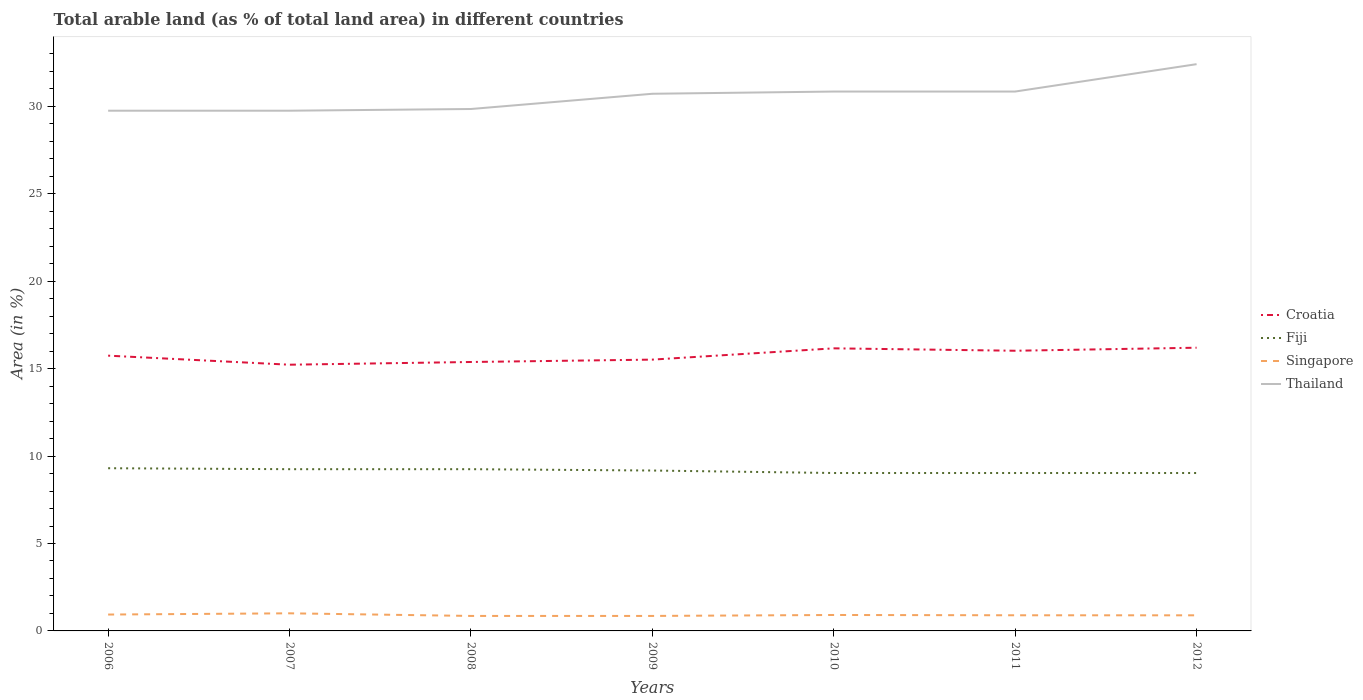How many different coloured lines are there?
Give a very brief answer. 4. Does the line corresponding to Fiji intersect with the line corresponding to Croatia?
Your answer should be compact. No. Is the number of lines equal to the number of legend labels?
Your answer should be very brief. Yes. Across all years, what is the maximum percentage of arable land in Fiji?
Ensure brevity in your answer.  9.03. In which year was the percentage of arable land in Thailand maximum?
Your answer should be very brief. 2006. What is the total percentage of arable land in Singapore in the graph?
Offer a terse response. 0.02. What is the difference between the highest and the second highest percentage of arable land in Croatia?
Keep it short and to the point. 0.97. What is the difference between the highest and the lowest percentage of arable land in Thailand?
Offer a terse response. 4. Is the percentage of arable land in Fiji strictly greater than the percentage of arable land in Singapore over the years?
Offer a very short reply. No. How many lines are there?
Ensure brevity in your answer.  4. What is the difference between two consecutive major ticks on the Y-axis?
Give a very brief answer. 5. How are the legend labels stacked?
Give a very brief answer. Vertical. What is the title of the graph?
Make the answer very short. Total arable land (as % of total land area) in different countries. What is the label or title of the X-axis?
Keep it short and to the point. Years. What is the label or title of the Y-axis?
Give a very brief answer. Area (in %). What is the Area (in %) in Croatia in 2006?
Make the answer very short. 15.74. What is the Area (in %) in Fiji in 2006?
Provide a succinct answer. 9.3. What is the Area (in %) of Singapore in 2006?
Provide a short and direct response. 0.94. What is the Area (in %) of Thailand in 2006?
Offer a terse response. 29.75. What is the Area (in %) of Croatia in 2007?
Give a very brief answer. 15.23. What is the Area (in %) in Fiji in 2007?
Your response must be concise. 9.25. What is the Area (in %) in Singapore in 2007?
Your response must be concise. 1.01. What is the Area (in %) in Thailand in 2007?
Give a very brief answer. 29.75. What is the Area (in %) in Croatia in 2008?
Make the answer very short. 15.38. What is the Area (in %) in Fiji in 2008?
Give a very brief answer. 9.25. What is the Area (in %) in Singapore in 2008?
Provide a short and direct response. 0.86. What is the Area (in %) of Thailand in 2008?
Your response must be concise. 29.85. What is the Area (in %) of Croatia in 2009?
Ensure brevity in your answer.  15.52. What is the Area (in %) of Fiji in 2009?
Your answer should be compact. 9.17. What is the Area (in %) of Singapore in 2009?
Make the answer very short. 0.86. What is the Area (in %) in Thailand in 2009?
Keep it short and to the point. 30.72. What is the Area (in %) in Croatia in 2010?
Provide a succinct answer. 16.16. What is the Area (in %) of Fiji in 2010?
Your answer should be compact. 9.03. What is the Area (in %) in Singapore in 2010?
Provide a succinct answer. 0.91. What is the Area (in %) of Thailand in 2010?
Offer a terse response. 30.85. What is the Area (in %) of Croatia in 2011?
Make the answer very short. 16.02. What is the Area (in %) in Fiji in 2011?
Provide a succinct answer. 9.03. What is the Area (in %) of Singapore in 2011?
Keep it short and to the point. 0.89. What is the Area (in %) in Thailand in 2011?
Keep it short and to the point. 30.85. What is the Area (in %) in Croatia in 2012?
Give a very brief answer. 16.2. What is the Area (in %) of Fiji in 2012?
Your answer should be very brief. 9.03. What is the Area (in %) of Singapore in 2012?
Offer a terse response. 0.89. What is the Area (in %) of Thailand in 2012?
Offer a terse response. 32.41. Across all years, what is the maximum Area (in %) of Croatia?
Your answer should be compact. 16.2. Across all years, what is the maximum Area (in %) of Fiji?
Give a very brief answer. 9.3. Across all years, what is the maximum Area (in %) in Singapore?
Ensure brevity in your answer.  1.01. Across all years, what is the maximum Area (in %) of Thailand?
Your answer should be compact. 32.41. Across all years, what is the minimum Area (in %) of Croatia?
Provide a succinct answer. 15.23. Across all years, what is the minimum Area (in %) of Fiji?
Provide a succinct answer. 9.03. Across all years, what is the minimum Area (in %) of Singapore?
Offer a very short reply. 0.86. Across all years, what is the minimum Area (in %) in Thailand?
Give a very brief answer. 29.75. What is the total Area (in %) in Croatia in the graph?
Your answer should be compact. 110.25. What is the total Area (in %) of Fiji in the graph?
Provide a succinct answer. 64.07. What is the total Area (in %) in Singapore in the graph?
Offer a terse response. 6.36. What is the total Area (in %) of Thailand in the graph?
Make the answer very short. 214.19. What is the difference between the Area (in %) of Croatia in 2006 and that in 2007?
Your answer should be compact. 0.52. What is the difference between the Area (in %) of Fiji in 2006 and that in 2007?
Give a very brief answer. 0.05. What is the difference between the Area (in %) of Singapore in 2006 and that in 2007?
Your answer should be very brief. -0.07. What is the difference between the Area (in %) of Croatia in 2006 and that in 2008?
Your response must be concise. 0.36. What is the difference between the Area (in %) of Fiji in 2006 and that in 2008?
Your answer should be compact. 0.05. What is the difference between the Area (in %) in Singapore in 2006 and that in 2008?
Provide a short and direct response. 0.08. What is the difference between the Area (in %) of Thailand in 2006 and that in 2008?
Give a very brief answer. -0.1. What is the difference between the Area (in %) in Croatia in 2006 and that in 2009?
Make the answer very short. 0.23. What is the difference between the Area (in %) of Fiji in 2006 and that in 2009?
Provide a short and direct response. 0.13. What is the difference between the Area (in %) in Singapore in 2006 and that in 2009?
Make the answer very short. 0.08. What is the difference between the Area (in %) of Thailand in 2006 and that in 2009?
Your answer should be compact. -0.97. What is the difference between the Area (in %) in Croatia in 2006 and that in 2010?
Your response must be concise. -0.42. What is the difference between the Area (in %) in Fiji in 2006 and that in 2010?
Provide a succinct answer. 0.27. What is the difference between the Area (in %) in Singapore in 2006 and that in 2010?
Give a very brief answer. 0.02. What is the difference between the Area (in %) of Thailand in 2006 and that in 2010?
Keep it short and to the point. -1.1. What is the difference between the Area (in %) of Croatia in 2006 and that in 2011?
Offer a terse response. -0.28. What is the difference between the Area (in %) of Fiji in 2006 and that in 2011?
Make the answer very short. 0.27. What is the difference between the Area (in %) of Singapore in 2006 and that in 2011?
Give a very brief answer. 0.04. What is the difference between the Area (in %) in Thailand in 2006 and that in 2011?
Provide a short and direct response. -1.1. What is the difference between the Area (in %) of Croatia in 2006 and that in 2012?
Keep it short and to the point. -0.45. What is the difference between the Area (in %) of Fiji in 2006 and that in 2012?
Your answer should be compact. 0.27. What is the difference between the Area (in %) of Singapore in 2006 and that in 2012?
Offer a very short reply. 0.04. What is the difference between the Area (in %) of Thailand in 2006 and that in 2012?
Keep it short and to the point. -2.66. What is the difference between the Area (in %) of Croatia in 2007 and that in 2008?
Your answer should be very brief. -0.16. What is the difference between the Area (in %) in Fiji in 2007 and that in 2008?
Your response must be concise. 0. What is the difference between the Area (in %) in Singapore in 2007 and that in 2008?
Ensure brevity in your answer.  0.15. What is the difference between the Area (in %) of Thailand in 2007 and that in 2008?
Your answer should be compact. -0.1. What is the difference between the Area (in %) in Croatia in 2007 and that in 2009?
Provide a short and direct response. -0.29. What is the difference between the Area (in %) of Fiji in 2007 and that in 2009?
Offer a terse response. 0.08. What is the difference between the Area (in %) in Singapore in 2007 and that in 2009?
Provide a short and direct response. 0.15. What is the difference between the Area (in %) of Thailand in 2007 and that in 2009?
Give a very brief answer. -0.97. What is the difference between the Area (in %) in Croatia in 2007 and that in 2010?
Your response must be concise. -0.94. What is the difference between the Area (in %) in Fiji in 2007 and that in 2010?
Make the answer very short. 0.22. What is the difference between the Area (in %) of Singapore in 2007 and that in 2010?
Your answer should be compact. 0.1. What is the difference between the Area (in %) of Thailand in 2007 and that in 2010?
Give a very brief answer. -1.1. What is the difference between the Area (in %) in Croatia in 2007 and that in 2011?
Keep it short and to the point. -0.8. What is the difference between the Area (in %) of Fiji in 2007 and that in 2011?
Provide a short and direct response. 0.22. What is the difference between the Area (in %) in Singapore in 2007 and that in 2011?
Keep it short and to the point. 0.11. What is the difference between the Area (in %) in Thailand in 2007 and that in 2011?
Offer a terse response. -1.1. What is the difference between the Area (in %) of Croatia in 2007 and that in 2012?
Your answer should be compact. -0.97. What is the difference between the Area (in %) in Fiji in 2007 and that in 2012?
Offer a terse response. 0.22. What is the difference between the Area (in %) in Singapore in 2007 and that in 2012?
Offer a very short reply. 0.11. What is the difference between the Area (in %) of Thailand in 2007 and that in 2012?
Your answer should be very brief. -2.66. What is the difference between the Area (in %) in Croatia in 2008 and that in 2009?
Give a very brief answer. -0.14. What is the difference between the Area (in %) of Fiji in 2008 and that in 2009?
Make the answer very short. 0.08. What is the difference between the Area (in %) of Singapore in 2008 and that in 2009?
Ensure brevity in your answer.  0. What is the difference between the Area (in %) of Thailand in 2008 and that in 2009?
Offer a very short reply. -0.87. What is the difference between the Area (in %) in Croatia in 2008 and that in 2010?
Provide a short and direct response. -0.78. What is the difference between the Area (in %) of Fiji in 2008 and that in 2010?
Provide a short and direct response. 0.22. What is the difference between the Area (in %) of Singapore in 2008 and that in 2010?
Offer a terse response. -0.05. What is the difference between the Area (in %) of Thailand in 2008 and that in 2010?
Provide a short and direct response. -1. What is the difference between the Area (in %) in Croatia in 2008 and that in 2011?
Offer a very short reply. -0.64. What is the difference between the Area (in %) in Fiji in 2008 and that in 2011?
Offer a terse response. 0.22. What is the difference between the Area (in %) in Singapore in 2008 and that in 2011?
Offer a terse response. -0.04. What is the difference between the Area (in %) of Thailand in 2008 and that in 2011?
Provide a succinct answer. -1. What is the difference between the Area (in %) of Croatia in 2008 and that in 2012?
Provide a succinct answer. -0.82. What is the difference between the Area (in %) in Fiji in 2008 and that in 2012?
Your answer should be compact. 0.22. What is the difference between the Area (in %) in Singapore in 2008 and that in 2012?
Make the answer very short. -0.04. What is the difference between the Area (in %) in Thailand in 2008 and that in 2012?
Keep it short and to the point. -2.56. What is the difference between the Area (in %) in Croatia in 2009 and that in 2010?
Provide a succinct answer. -0.65. What is the difference between the Area (in %) of Fiji in 2009 and that in 2010?
Offer a terse response. 0.14. What is the difference between the Area (in %) in Singapore in 2009 and that in 2010?
Give a very brief answer. -0.05. What is the difference between the Area (in %) of Thailand in 2009 and that in 2010?
Your answer should be compact. -0.13. What is the difference between the Area (in %) in Croatia in 2009 and that in 2011?
Your answer should be compact. -0.51. What is the difference between the Area (in %) in Fiji in 2009 and that in 2011?
Offer a terse response. 0.14. What is the difference between the Area (in %) in Singapore in 2009 and that in 2011?
Ensure brevity in your answer.  -0.04. What is the difference between the Area (in %) of Thailand in 2009 and that in 2011?
Provide a short and direct response. -0.13. What is the difference between the Area (in %) of Croatia in 2009 and that in 2012?
Offer a very short reply. -0.68. What is the difference between the Area (in %) of Fiji in 2009 and that in 2012?
Keep it short and to the point. 0.14. What is the difference between the Area (in %) in Singapore in 2009 and that in 2012?
Make the answer very short. -0.04. What is the difference between the Area (in %) in Thailand in 2009 and that in 2012?
Give a very brief answer. -1.69. What is the difference between the Area (in %) of Croatia in 2010 and that in 2011?
Make the answer very short. 0.14. What is the difference between the Area (in %) of Fiji in 2010 and that in 2011?
Offer a terse response. 0. What is the difference between the Area (in %) in Singapore in 2010 and that in 2011?
Provide a short and direct response. 0.02. What is the difference between the Area (in %) of Croatia in 2010 and that in 2012?
Offer a very short reply. -0.04. What is the difference between the Area (in %) in Singapore in 2010 and that in 2012?
Your answer should be very brief. 0.02. What is the difference between the Area (in %) of Thailand in 2010 and that in 2012?
Ensure brevity in your answer.  -1.57. What is the difference between the Area (in %) of Croatia in 2011 and that in 2012?
Offer a very short reply. -0.17. What is the difference between the Area (in %) in Fiji in 2011 and that in 2012?
Your answer should be compact. 0. What is the difference between the Area (in %) of Singapore in 2011 and that in 2012?
Your response must be concise. 0. What is the difference between the Area (in %) of Thailand in 2011 and that in 2012?
Your response must be concise. -1.57. What is the difference between the Area (in %) of Croatia in 2006 and the Area (in %) of Fiji in 2007?
Your answer should be compact. 6.49. What is the difference between the Area (in %) in Croatia in 2006 and the Area (in %) in Singapore in 2007?
Your response must be concise. 14.74. What is the difference between the Area (in %) of Croatia in 2006 and the Area (in %) of Thailand in 2007?
Ensure brevity in your answer.  -14.01. What is the difference between the Area (in %) in Fiji in 2006 and the Area (in %) in Singapore in 2007?
Make the answer very short. 8.3. What is the difference between the Area (in %) in Fiji in 2006 and the Area (in %) in Thailand in 2007?
Your response must be concise. -20.45. What is the difference between the Area (in %) of Singapore in 2006 and the Area (in %) of Thailand in 2007?
Keep it short and to the point. -28.82. What is the difference between the Area (in %) of Croatia in 2006 and the Area (in %) of Fiji in 2008?
Your response must be concise. 6.49. What is the difference between the Area (in %) in Croatia in 2006 and the Area (in %) in Singapore in 2008?
Provide a succinct answer. 14.89. What is the difference between the Area (in %) of Croatia in 2006 and the Area (in %) of Thailand in 2008?
Ensure brevity in your answer.  -14.11. What is the difference between the Area (in %) of Fiji in 2006 and the Area (in %) of Singapore in 2008?
Ensure brevity in your answer.  8.45. What is the difference between the Area (in %) in Fiji in 2006 and the Area (in %) in Thailand in 2008?
Your response must be concise. -20.55. What is the difference between the Area (in %) in Singapore in 2006 and the Area (in %) in Thailand in 2008?
Offer a very short reply. -28.91. What is the difference between the Area (in %) of Croatia in 2006 and the Area (in %) of Fiji in 2009?
Offer a terse response. 6.57. What is the difference between the Area (in %) in Croatia in 2006 and the Area (in %) in Singapore in 2009?
Make the answer very short. 14.89. What is the difference between the Area (in %) in Croatia in 2006 and the Area (in %) in Thailand in 2009?
Make the answer very short. -14.98. What is the difference between the Area (in %) in Fiji in 2006 and the Area (in %) in Singapore in 2009?
Provide a succinct answer. 8.45. What is the difference between the Area (in %) of Fiji in 2006 and the Area (in %) of Thailand in 2009?
Make the answer very short. -21.42. What is the difference between the Area (in %) in Singapore in 2006 and the Area (in %) in Thailand in 2009?
Your answer should be compact. -29.78. What is the difference between the Area (in %) in Croatia in 2006 and the Area (in %) in Fiji in 2010?
Your answer should be compact. 6.71. What is the difference between the Area (in %) in Croatia in 2006 and the Area (in %) in Singapore in 2010?
Provide a short and direct response. 14.83. What is the difference between the Area (in %) of Croatia in 2006 and the Area (in %) of Thailand in 2010?
Keep it short and to the point. -15.1. What is the difference between the Area (in %) in Fiji in 2006 and the Area (in %) in Singapore in 2010?
Offer a terse response. 8.39. What is the difference between the Area (in %) in Fiji in 2006 and the Area (in %) in Thailand in 2010?
Offer a terse response. -21.54. What is the difference between the Area (in %) of Singapore in 2006 and the Area (in %) of Thailand in 2010?
Ensure brevity in your answer.  -29.91. What is the difference between the Area (in %) in Croatia in 2006 and the Area (in %) in Fiji in 2011?
Keep it short and to the point. 6.71. What is the difference between the Area (in %) in Croatia in 2006 and the Area (in %) in Singapore in 2011?
Your response must be concise. 14.85. What is the difference between the Area (in %) in Croatia in 2006 and the Area (in %) in Thailand in 2011?
Provide a succinct answer. -15.1. What is the difference between the Area (in %) in Fiji in 2006 and the Area (in %) in Singapore in 2011?
Your answer should be very brief. 8.41. What is the difference between the Area (in %) in Fiji in 2006 and the Area (in %) in Thailand in 2011?
Provide a succinct answer. -21.54. What is the difference between the Area (in %) of Singapore in 2006 and the Area (in %) of Thailand in 2011?
Keep it short and to the point. -29.91. What is the difference between the Area (in %) of Croatia in 2006 and the Area (in %) of Fiji in 2012?
Make the answer very short. 6.71. What is the difference between the Area (in %) of Croatia in 2006 and the Area (in %) of Singapore in 2012?
Offer a terse response. 14.85. What is the difference between the Area (in %) in Croatia in 2006 and the Area (in %) in Thailand in 2012?
Ensure brevity in your answer.  -16.67. What is the difference between the Area (in %) of Fiji in 2006 and the Area (in %) of Singapore in 2012?
Keep it short and to the point. 8.41. What is the difference between the Area (in %) in Fiji in 2006 and the Area (in %) in Thailand in 2012?
Give a very brief answer. -23.11. What is the difference between the Area (in %) in Singapore in 2006 and the Area (in %) in Thailand in 2012?
Provide a succinct answer. -31.48. What is the difference between the Area (in %) in Croatia in 2007 and the Area (in %) in Fiji in 2008?
Your answer should be very brief. 5.97. What is the difference between the Area (in %) in Croatia in 2007 and the Area (in %) in Singapore in 2008?
Give a very brief answer. 14.37. What is the difference between the Area (in %) in Croatia in 2007 and the Area (in %) in Thailand in 2008?
Offer a very short reply. -14.62. What is the difference between the Area (in %) of Fiji in 2007 and the Area (in %) of Singapore in 2008?
Offer a terse response. 8.39. What is the difference between the Area (in %) in Fiji in 2007 and the Area (in %) in Thailand in 2008?
Ensure brevity in your answer.  -20.6. What is the difference between the Area (in %) in Singapore in 2007 and the Area (in %) in Thailand in 2008?
Give a very brief answer. -28.84. What is the difference between the Area (in %) of Croatia in 2007 and the Area (in %) of Fiji in 2009?
Your response must be concise. 6.05. What is the difference between the Area (in %) of Croatia in 2007 and the Area (in %) of Singapore in 2009?
Provide a succinct answer. 14.37. What is the difference between the Area (in %) in Croatia in 2007 and the Area (in %) in Thailand in 2009?
Ensure brevity in your answer.  -15.5. What is the difference between the Area (in %) in Fiji in 2007 and the Area (in %) in Singapore in 2009?
Make the answer very short. 8.39. What is the difference between the Area (in %) in Fiji in 2007 and the Area (in %) in Thailand in 2009?
Your answer should be compact. -21.47. What is the difference between the Area (in %) in Singapore in 2007 and the Area (in %) in Thailand in 2009?
Ensure brevity in your answer.  -29.71. What is the difference between the Area (in %) in Croatia in 2007 and the Area (in %) in Fiji in 2010?
Your answer should be compact. 6.19. What is the difference between the Area (in %) of Croatia in 2007 and the Area (in %) of Singapore in 2010?
Keep it short and to the point. 14.31. What is the difference between the Area (in %) in Croatia in 2007 and the Area (in %) in Thailand in 2010?
Provide a short and direct response. -15.62. What is the difference between the Area (in %) of Fiji in 2007 and the Area (in %) of Singapore in 2010?
Ensure brevity in your answer.  8.34. What is the difference between the Area (in %) of Fiji in 2007 and the Area (in %) of Thailand in 2010?
Your response must be concise. -21.6. What is the difference between the Area (in %) in Singapore in 2007 and the Area (in %) in Thailand in 2010?
Your response must be concise. -29.84. What is the difference between the Area (in %) of Croatia in 2007 and the Area (in %) of Fiji in 2011?
Offer a terse response. 6.19. What is the difference between the Area (in %) of Croatia in 2007 and the Area (in %) of Singapore in 2011?
Your response must be concise. 14.33. What is the difference between the Area (in %) of Croatia in 2007 and the Area (in %) of Thailand in 2011?
Keep it short and to the point. -15.62. What is the difference between the Area (in %) of Fiji in 2007 and the Area (in %) of Singapore in 2011?
Your answer should be compact. 8.36. What is the difference between the Area (in %) of Fiji in 2007 and the Area (in %) of Thailand in 2011?
Ensure brevity in your answer.  -21.6. What is the difference between the Area (in %) of Singapore in 2007 and the Area (in %) of Thailand in 2011?
Provide a succinct answer. -29.84. What is the difference between the Area (in %) in Croatia in 2007 and the Area (in %) in Fiji in 2012?
Your answer should be compact. 6.19. What is the difference between the Area (in %) of Croatia in 2007 and the Area (in %) of Singapore in 2012?
Provide a short and direct response. 14.33. What is the difference between the Area (in %) in Croatia in 2007 and the Area (in %) in Thailand in 2012?
Your answer should be compact. -17.19. What is the difference between the Area (in %) of Fiji in 2007 and the Area (in %) of Singapore in 2012?
Offer a terse response. 8.36. What is the difference between the Area (in %) of Fiji in 2007 and the Area (in %) of Thailand in 2012?
Your answer should be compact. -23.16. What is the difference between the Area (in %) of Singapore in 2007 and the Area (in %) of Thailand in 2012?
Make the answer very short. -31.41. What is the difference between the Area (in %) of Croatia in 2008 and the Area (in %) of Fiji in 2009?
Provide a short and direct response. 6.21. What is the difference between the Area (in %) in Croatia in 2008 and the Area (in %) in Singapore in 2009?
Your answer should be compact. 14.52. What is the difference between the Area (in %) in Croatia in 2008 and the Area (in %) in Thailand in 2009?
Make the answer very short. -15.34. What is the difference between the Area (in %) of Fiji in 2008 and the Area (in %) of Singapore in 2009?
Offer a terse response. 8.39. What is the difference between the Area (in %) in Fiji in 2008 and the Area (in %) in Thailand in 2009?
Give a very brief answer. -21.47. What is the difference between the Area (in %) in Singapore in 2008 and the Area (in %) in Thailand in 2009?
Ensure brevity in your answer.  -29.86. What is the difference between the Area (in %) of Croatia in 2008 and the Area (in %) of Fiji in 2010?
Give a very brief answer. 6.35. What is the difference between the Area (in %) of Croatia in 2008 and the Area (in %) of Singapore in 2010?
Your answer should be compact. 14.47. What is the difference between the Area (in %) of Croatia in 2008 and the Area (in %) of Thailand in 2010?
Your response must be concise. -15.47. What is the difference between the Area (in %) of Fiji in 2008 and the Area (in %) of Singapore in 2010?
Offer a very short reply. 8.34. What is the difference between the Area (in %) in Fiji in 2008 and the Area (in %) in Thailand in 2010?
Keep it short and to the point. -21.6. What is the difference between the Area (in %) of Singapore in 2008 and the Area (in %) of Thailand in 2010?
Provide a short and direct response. -29.99. What is the difference between the Area (in %) of Croatia in 2008 and the Area (in %) of Fiji in 2011?
Give a very brief answer. 6.35. What is the difference between the Area (in %) of Croatia in 2008 and the Area (in %) of Singapore in 2011?
Offer a terse response. 14.49. What is the difference between the Area (in %) of Croatia in 2008 and the Area (in %) of Thailand in 2011?
Offer a terse response. -15.47. What is the difference between the Area (in %) in Fiji in 2008 and the Area (in %) in Singapore in 2011?
Offer a terse response. 8.36. What is the difference between the Area (in %) of Fiji in 2008 and the Area (in %) of Thailand in 2011?
Offer a terse response. -21.6. What is the difference between the Area (in %) in Singapore in 2008 and the Area (in %) in Thailand in 2011?
Your answer should be very brief. -29.99. What is the difference between the Area (in %) of Croatia in 2008 and the Area (in %) of Fiji in 2012?
Ensure brevity in your answer.  6.35. What is the difference between the Area (in %) of Croatia in 2008 and the Area (in %) of Singapore in 2012?
Provide a succinct answer. 14.49. What is the difference between the Area (in %) of Croatia in 2008 and the Area (in %) of Thailand in 2012?
Give a very brief answer. -17.03. What is the difference between the Area (in %) in Fiji in 2008 and the Area (in %) in Singapore in 2012?
Your answer should be very brief. 8.36. What is the difference between the Area (in %) of Fiji in 2008 and the Area (in %) of Thailand in 2012?
Your response must be concise. -23.16. What is the difference between the Area (in %) of Singapore in 2008 and the Area (in %) of Thailand in 2012?
Offer a very short reply. -31.56. What is the difference between the Area (in %) of Croatia in 2009 and the Area (in %) of Fiji in 2010?
Provide a succinct answer. 6.49. What is the difference between the Area (in %) of Croatia in 2009 and the Area (in %) of Singapore in 2010?
Offer a very short reply. 14.6. What is the difference between the Area (in %) of Croatia in 2009 and the Area (in %) of Thailand in 2010?
Keep it short and to the point. -15.33. What is the difference between the Area (in %) in Fiji in 2009 and the Area (in %) in Singapore in 2010?
Make the answer very short. 8.26. What is the difference between the Area (in %) in Fiji in 2009 and the Area (in %) in Thailand in 2010?
Provide a short and direct response. -21.67. What is the difference between the Area (in %) of Singapore in 2009 and the Area (in %) of Thailand in 2010?
Ensure brevity in your answer.  -29.99. What is the difference between the Area (in %) of Croatia in 2009 and the Area (in %) of Fiji in 2011?
Offer a very short reply. 6.49. What is the difference between the Area (in %) of Croatia in 2009 and the Area (in %) of Singapore in 2011?
Make the answer very short. 14.62. What is the difference between the Area (in %) of Croatia in 2009 and the Area (in %) of Thailand in 2011?
Offer a terse response. -15.33. What is the difference between the Area (in %) of Fiji in 2009 and the Area (in %) of Singapore in 2011?
Offer a terse response. 8.28. What is the difference between the Area (in %) of Fiji in 2009 and the Area (in %) of Thailand in 2011?
Provide a succinct answer. -21.67. What is the difference between the Area (in %) in Singapore in 2009 and the Area (in %) in Thailand in 2011?
Offer a very short reply. -29.99. What is the difference between the Area (in %) in Croatia in 2009 and the Area (in %) in Fiji in 2012?
Keep it short and to the point. 6.49. What is the difference between the Area (in %) in Croatia in 2009 and the Area (in %) in Singapore in 2012?
Your answer should be very brief. 14.62. What is the difference between the Area (in %) in Croatia in 2009 and the Area (in %) in Thailand in 2012?
Offer a terse response. -16.9. What is the difference between the Area (in %) in Fiji in 2009 and the Area (in %) in Singapore in 2012?
Ensure brevity in your answer.  8.28. What is the difference between the Area (in %) in Fiji in 2009 and the Area (in %) in Thailand in 2012?
Keep it short and to the point. -23.24. What is the difference between the Area (in %) of Singapore in 2009 and the Area (in %) of Thailand in 2012?
Give a very brief answer. -31.56. What is the difference between the Area (in %) in Croatia in 2010 and the Area (in %) in Fiji in 2011?
Offer a very short reply. 7.13. What is the difference between the Area (in %) of Croatia in 2010 and the Area (in %) of Singapore in 2011?
Your answer should be compact. 15.27. What is the difference between the Area (in %) of Croatia in 2010 and the Area (in %) of Thailand in 2011?
Your response must be concise. -14.69. What is the difference between the Area (in %) in Fiji in 2010 and the Area (in %) in Singapore in 2011?
Offer a very short reply. 8.14. What is the difference between the Area (in %) of Fiji in 2010 and the Area (in %) of Thailand in 2011?
Provide a succinct answer. -21.82. What is the difference between the Area (in %) of Singapore in 2010 and the Area (in %) of Thailand in 2011?
Provide a succinct answer. -29.94. What is the difference between the Area (in %) of Croatia in 2010 and the Area (in %) of Fiji in 2012?
Provide a short and direct response. 7.13. What is the difference between the Area (in %) of Croatia in 2010 and the Area (in %) of Singapore in 2012?
Make the answer very short. 15.27. What is the difference between the Area (in %) in Croatia in 2010 and the Area (in %) in Thailand in 2012?
Keep it short and to the point. -16.25. What is the difference between the Area (in %) in Fiji in 2010 and the Area (in %) in Singapore in 2012?
Ensure brevity in your answer.  8.14. What is the difference between the Area (in %) of Fiji in 2010 and the Area (in %) of Thailand in 2012?
Your response must be concise. -23.38. What is the difference between the Area (in %) of Singapore in 2010 and the Area (in %) of Thailand in 2012?
Give a very brief answer. -31.5. What is the difference between the Area (in %) of Croatia in 2011 and the Area (in %) of Fiji in 2012?
Provide a short and direct response. 6.99. What is the difference between the Area (in %) of Croatia in 2011 and the Area (in %) of Singapore in 2012?
Give a very brief answer. 15.13. What is the difference between the Area (in %) in Croatia in 2011 and the Area (in %) in Thailand in 2012?
Provide a short and direct response. -16.39. What is the difference between the Area (in %) in Fiji in 2011 and the Area (in %) in Singapore in 2012?
Provide a succinct answer. 8.14. What is the difference between the Area (in %) in Fiji in 2011 and the Area (in %) in Thailand in 2012?
Give a very brief answer. -23.38. What is the difference between the Area (in %) of Singapore in 2011 and the Area (in %) of Thailand in 2012?
Make the answer very short. -31.52. What is the average Area (in %) in Croatia per year?
Your response must be concise. 15.75. What is the average Area (in %) in Fiji per year?
Give a very brief answer. 9.15. What is the average Area (in %) of Singapore per year?
Your response must be concise. 0.91. What is the average Area (in %) in Thailand per year?
Offer a terse response. 30.6. In the year 2006, what is the difference between the Area (in %) of Croatia and Area (in %) of Fiji?
Your answer should be compact. 6.44. In the year 2006, what is the difference between the Area (in %) in Croatia and Area (in %) in Singapore?
Your answer should be very brief. 14.81. In the year 2006, what is the difference between the Area (in %) of Croatia and Area (in %) of Thailand?
Provide a succinct answer. -14.01. In the year 2006, what is the difference between the Area (in %) in Fiji and Area (in %) in Singapore?
Keep it short and to the point. 8.37. In the year 2006, what is the difference between the Area (in %) in Fiji and Area (in %) in Thailand?
Provide a short and direct response. -20.45. In the year 2006, what is the difference between the Area (in %) in Singapore and Area (in %) in Thailand?
Offer a very short reply. -28.82. In the year 2007, what is the difference between the Area (in %) in Croatia and Area (in %) in Fiji?
Provide a succinct answer. 5.97. In the year 2007, what is the difference between the Area (in %) of Croatia and Area (in %) of Singapore?
Keep it short and to the point. 14.22. In the year 2007, what is the difference between the Area (in %) in Croatia and Area (in %) in Thailand?
Give a very brief answer. -14.53. In the year 2007, what is the difference between the Area (in %) in Fiji and Area (in %) in Singapore?
Give a very brief answer. 8.24. In the year 2007, what is the difference between the Area (in %) in Fiji and Area (in %) in Thailand?
Provide a succinct answer. -20.5. In the year 2007, what is the difference between the Area (in %) of Singapore and Area (in %) of Thailand?
Offer a terse response. -28.74. In the year 2008, what is the difference between the Area (in %) in Croatia and Area (in %) in Fiji?
Keep it short and to the point. 6.13. In the year 2008, what is the difference between the Area (in %) in Croatia and Area (in %) in Singapore?
Your response must be concise. 14.52. In the year 2008, what is the difference between the Area (in %) of Croatia and Area (in %) of Thailand?
Make the answer very short. -14.47. In the year 2008, what is the difference between the Area (in %) of Fiji and Area (in %) of Singapore?
Give a very brief answer. 8.39. In the year 2008, what is the difference between the Area (in %) of Fiji and Area (in %) of Thailand?
Your response must be concise. -20.6. In the year 2008, what is the difference between the Area (in %) of Singapore and Area (in %) of Thailand?
Your answer should be very brief. -28.99. In the year 2009, what is the difference between the Area (in %) of Croatia and Area (in %) of Fiji?
Your answer should be very brief. 6.34. In the year 2009, what is the difference between the Area (in %) of Croatia and Area (in %) of Singapore?
Make the answer very short. 14.66. In the year 2009, what is the difference between the Area (in %) in Croatia and Area (in %) in Thailand?
Your answer should be compact. -15.2. In the year 2009, what is the difference between the Area (in %) in Fiji and Area (in %) in Singapore?
Your answer should be compact. 8.32. In the year 2009, what is the difference between the Area (in %) of Fiji and Area (in %) of Thailand?
Provide a succinct answer. -21.55. In the year 2009, what is the difference between the Area (in %) of Singapore and Area (in %) of Thailand?
Give a very brief answer. -29.86. In the year 2010, what is the difference between the Area (in %) of Croatia and Area (in %) of Fiji?
Provide a short and direct response. 7.13. In the year 2010, what is the difference between the Area (in %) of Croatia and Area (in %) of Singapore?
Give a very brief answer. 15.25. In the year 2010, what is the difference between the Area (in %) of Croatia and Area (in %) of Thailand?
Give a very brief answer. -14.69. In the year 2010, what is the difference between the Area (in %) in Fiji and Area (in %) in Singapore?
Provide a succinct answer. 8.12. In the year 2010, what is the difference between the Area (in %) in Fiji and Area (in %) in Thailand?
Provide a short and direct response. -21.82. In the year 2010, what is the difference between the Area (in %) in Singapore and Area (in %) in Thailand?
Ensure brevity in your answer.  -29.94. In the year 2011, what is the difference between the Area (in %) in Croatia and Area (in %) in Fiji?
Give a very brief answer. 6.99. In the year 2011, what is the difference between the Area (in %) in Croatia and Area (in %) in Singapore?
Your response must be concise. 15.13. In the year 2011, what is the difference between the Area (in %) in Croatia and Area (in %) in Thailand?
Provide a succinct answer. -14.82. In the year 2011, what is the difference between the Area (in %) in Fiji and Area (in %) in Singapore?
Offer a very short reply. 8.14. In the year 2011, what is the difference between the Area (in %) in Fiji and Area (in %) in Thailand?
Provide a succinct answer. -21.82. In the year 2011, what is the difference between the Area (in %) of Singapore and Area (in %) of Thailand?
Offer a very short reply. -29.95. In the year 2012, what is the difference between the Area (in %) in Croatia and Area (in %) in Fiji?
Offer a very short reply. 7.17. In the year 2012, what is the difference between the Area (in %) in Croatia and Area (in %) in Singapore?
Your answer should be compact. 15.3. In the year 2012, what is the difference between the Area (in %) in Croatia and Area (in %) in Thailand?
Give a very brief answer. -16.22. In the year 2012, what is the difference between the Area (in %) of Fiji and Area (in %) of Singapore?
Your answer should be compact. 8.14. In the year 2012, what is the difference between the Area (in %) in Fiji and Area (in %) in Thailand?
Your answer should be compact. -23.38. In the year 2012, what is the difference between the Area (in %) in Singapore and Area (in %) in Thailand?
Offer a terse response. -31.52. What is the ratio of the Area (in %) in Croatia in 2006 to that in 2007?
Your response must be concise. 1.03. What is the ratio of the Area (in %) in Fiji in 2006 to that in 2007?
Make the answer very short. 1.01. What is the ratio of the Area (in %) of Singapore in 2006 to that in 2007?
Offer a very short reply. 0.93. What is the ratio of the Area (in %) in Croatia in 2006 to that in 2008?
Make the answer very short. 1.02. What is the ratio of the Area (in %) in Fiji in 2006 to that in 2008?
Your answer should be very brief. 1.01. What is the ratio of the Area (in %) of Singapore in 2006 to that in 2008?
Your answer should be very brief. 1.09. What is the ratio of the Area (in %) in Thailand in 2006 to that in 2008?
Your answer should be compact. 1. What is the ratio of the Area (in %) of Croatia in 2006 to that in 2009?
Your answer should be very brief. 1.01. What is the ratio of the Area (in %) in Fiji in 2006 to that in 2009?
Give a very brief answer. 1.01. What is the ratio of the Area (in %) in Singapore in 2006 to that in 2009?
Offer a terse response. 1.09. What is the ratio of the Area (in %) in Thailand in 2006 to that in 2009?
Offer a terse response. 0.97. What is the ratio of the Area (in %) of Croatia in 2006 to that in 2010?
Your answer should be very brief. 0.97. What is the ratio of the Area (in %) in Fiji in 2006 to that in 2010?
Give a very brief answer. 1.03. What is the ratio of the Area (in %) in Singapore in 2006 to that in 2010?
Provide a short and direct response. 1.03. What is the ratio of the Area (in %) in Thailand in 2006 to that in 2010?
Your response must be concise. 0.96. What is the ratio of the Area (in %) in Croatia in 2006 to that in 2011?
Offer a terse response. 0.98. What is the ratio of the Area (in %) in Fiji in 2006 to that in 2011?
Provide a short and direct response. 1.03. What is the ratio of the Area (in %) in Singapore in 2006 to that in 2011?
Offer a very short reply. 1.05. What is the ratio of the Area (in %) of Thailand in 2006 to that in 2011?
Your response must be concise. 0.96. What is the ratio of the Area (in %) of Fiji in 2006 to that in 2012?
Offer a terse response. 1.03. What is the ratio of the Area (in %) in Singapore in 2006 to that in 2012?
Your answer should be very brief. 1.05. What is the ratio of the Area (in %) of Thailand in 2006 to that in 2012?
Make the answer very short. 0.92. What is the ratio of the Area (in %) in Croatia in 2007 to that in 2008?
Ensure brevity in your answer.  0.99. What is the ratio of the Area (in %) in Fiji in 2007 to that in 2008?
Offer a very short reply. 1. What is the ratio of the Area (in %) of Singapore in 2007 to that in 2008?
Offer a very short reply. 1.18. What is the ratio of the Area (in %) of Thailand in 2007 to that in 2008?
Your response must be concise. 1. What is the ratio of the Area (in %) in Croatia in 2007 to that in 2009?
Provide a short and direct response. 0.98. What is the ratio of the Area (in %) of Fiji in 2007 to that in 2009?
Provide a short and direct response. 1.01. What is the ratio of the Area (in %) in Singapore in 2007 to that in 2009?
Offer a terse response. 1.18. What is the ratio of the Area (in %) in Thailand in 2007 to that in 2009?
Provide a succinct answer. 0.97. What is the ratio of the Area (in %) in Croatia in 2007 to that in 2010?
Offer a terse response. 0.94. What is the ratio of the Area (in %) in Fiji in 2007 to that in 2010?
Offer a terse response. 1.02. What is the ratio of the Area (in %) of Singapore in 2007 to that in 2010?
Provide a short and direct response. 1.1. What is the ratio of the Area (in %) in Thailand in 2007 to that in 2010?
Provide a succinct answer. 0.96. What is the ratio of the Area (in %) in Croatia in 2007 to that in 2011?
Keep it short and to the point. 0.95. What is the ratio of the Area (in %) of Fiji in 2007 to that in 2011?
Offer a very short reply. 1.02. What is the ratio of the Area (in %) in Singapore in 2007 to that in 2011?
Offer a terse response. 1.13. What is the ratio of the Area (in %) in Thailand in 2007 to that in 2011?
Your answer should be compact. 0.96. What is the ratio of the Area (in %) in Fiji in 2007 to that in 2012?
Keep it short and to the point. 1.02. What is the ratio of the Area (in %) of Singapore in 2007 to that in 2012?
Give a very brief answer. 1.13. What is the ratio of the Area (in %) in Thailand in 2007 to that in 2012?
Keep it short and to the point. 0.92. What is the ratio of the Area (in %) of Croatia in 2008 to that in 2009?
Keep it short and to the point. 0.99. What is the ratio of the Area (in %) in Fiji in 2008 to that in 2009?
Offer a very short reply. 1.01. What is the ratio of the Area (in %) in Singapore in 2008 to that in 2009?
Offer a very short reply. 1. What is the ratio of the Area (in %) in Thailand in 2008 to that in 2009?
Your response must be concise. 0.97. What is the ratio of the Area (in %) in Croatia in 2008 to that in 2010?
Offer a very short reply. 0.95. What is the ratio of the Area (in %) in Fiji in 2008 to that in 2010?
Provide a succinct answer. 1.02. What is the ratio of the Area (in %) in Singapore in 2008 to that in 2010?
Provide a short and direct response. 0.94. What is the ratio of the Area (in %) in Thailand in 2008 to that in 2010?
Give a very brief answer. 0.97. What is the ratio of the Area (in %) in Croatia in 2008 to that in 2011?
Offer a terse response. 0.96. What is the ratio of the Area (in %) in Fiji in 2008 to that in 2011?
Ensure brevity in your answer.  1.02. What is the ratio of the Area (in %) of Singapore in 2008 to that in 2011?
Ensure brevity in your answer.  0.96. What is the ratio of the Area (in %) in Thailand in 2008 to that in 2011?
Ensure brevity in your answer.  0.97. What is the ratio of the Area (in %) in Croatia in 2008 to that in 2012?
Your response must be concise. 0.95. What is the ratio of the Area (in %) of Fiji in 2008 to that in 2012?
Offer a very short reply. 1.02. What is the ratio of the Area (in %) of Singapore in 2008 to that in 2012?
Offer a terse response. 0.96. What is the ratio of the Area (in %) of Thailand in 2008 to that in 2012?
Your response must be concise. 0.92. What is the ratio of the Area (in %) in Croatia in 2009 to that in 2010?
Offer a very short reply. 0.96. What is the ratio of the Area (in %) in Fiji in 2009 to that in 2010?
Your answer should be very brief. 1.02. What is the ratio of the Area (in %) in Singapore in 2009 to that in 2010?
Provide a succinct answer. 0.94. What is the ratio of the Area (in %) in Thailand in 2009 to that in 2010?
Provide a succinct answer. 1. What is the ratio of the Area (in %) of Croatia in 2009 to that in 2011?
Offer a very short reply. 0.97. What is the ratio of the Area (in %) of Fiji in 2009 to that in 2011?
Offer a very short reply. 1.02. What is the ratio of the Area (in %) of Singapore in 2009 to that in 2011?
Offer a very short reply. 0.96. What is the ratio of the Area (in %) in Thailand in 2009 to that in 2011?
Your answer should be very brief. 1. What is the ratio of the Area (in %) in Croatia in 2009 to that in 2012?
Your answer should be compact. 0.96. What is the ratio of the Area (in %) in Fiji in 2009 to that in 2012?
Your response must be concise. 1.02. What is the ratio of the Area (in %) in Singapore in 2009 to that in 2012?
Your answer should be very brief. 0.96. What is the ratio of the Area (in %) in Thailand in 2009 to that in 2012?
Ensure brevity in your answer.  0.95. What is the ratio of the Area (in %) in Croatia in 2010 to that in 2011?
Offer a very short reply. 1.01. What is the ratio of the Area (in %) in Fiji in 2010 to that in 2011?
Give a very brief answer. 1. What is the ratio of the Area (in %) of Singapore in 2010 to that in 2011?
Offer a terse response. 1.02. What is the ratio of the Area (in %) of Thailand in 2010 to that in 2011?
Provide a short and direct response. 1. What is the ratio of the Area (in %) of Singapore in 2010 to that in 2012?
Ensure brevity in your answer.  1.02. What is the ratio of the Area (in %) of Thailand in 2010 to that in 2012?
Provide a short and direct response. 0.95. What is the ratio of the Area (in %) of Croatia in 2011 to that in 2012?
Provide a short and direct response. 0.99. What is the ratio of the Area (in %) in Thailand in 2011 to that in 2012?
Provide a short and direct response. 0.95. What is the difference between the highest and the second highest Area (in %) of Croatia?
Offer a terse response. 0.04. What is the difference between the highest and the second highest Area (in %) of Fiji?
Give a very brief answer. 0.05. What is the difference between the highest and the second highest Area (in %) of Singapore?
Provide a succinct answer. 0.07. What is the difference between the highest and the second highest Area (in %) in Thailand?
Your answer should be compact. 1.57. What is the difference between the highest and the lowest Area (in %) of Croatia?
Your response must be concise. 0.97. What is the difference between the highest and the lowest Area (in %) in Fiji?
Your response must be concise. 0.27. What is the difference between the highest and the lowest Area (in %) in Singapore?
Your answer should be very brief. 0.15. What is the difference between the highest and the lowest Area (in %) in Thailand?
Give a very brief answer. 2.66. 